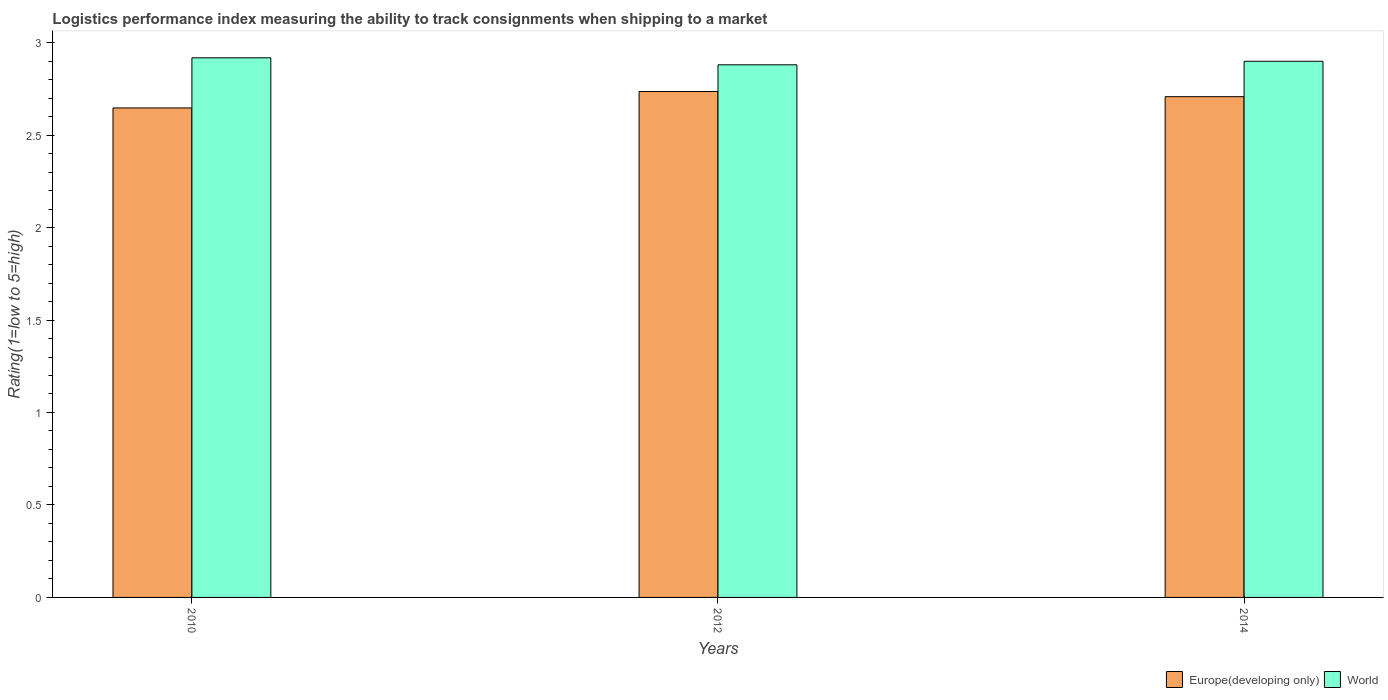How many different coloured bars are there?
Keep it short and to the point. 2. How many groups of bars are there?
Ensure brevity in your answer.  3. Are the number of bars on each tick of the X-axis equal?
Give a very brief answer. Yes. How many bars are there on the 2nd tick from the left?
Keep it short and to the point. 2. How many bars are there on the 2nd tick from the right?
Offer a terse response. 2. In how many cases, is the number of bars for a given year not equal to the number of legend labels?
Provide a succinct answer. 0. What is the Logistic performance index in Europe(developing only) in 2012?
Make the answer very short. 2.74. Across all years, what is the maximum Logistic performance index in World?
Keep it short and to the point. 2.92. Across all years, what is the minimum Logistic performance index in World?
Offer a very short reply. 2.88. In which year was the Logistic performance index in World maximum?
Offer a terse response. 2010. What is the total Logistic performance index in Europe(developing only) in the graph?
Offer a very short reply. 8.09. What is the difference between the Logistic performance index in Europe(developing only) in 2010 and that in 2014?
Provide a short and direct response. -0.06. What is the difference between the Logistic performance index in World in 2010 and the Logistic performance index in Europe(developing only) in 2014?
Offer a terse response. 0.21. What is the average Logistic performance index in World per year?
Give a very brief answer. 2.9. In the year 2010, what is the difference between the Logistic performance index in World and Logistic performance index in Europe(developing only)?
Offer a terse response. 0.27. What is the ratio of the Logistic performance index in World in 2010 to that in 2012?
Offer a very short reply. 1.01. Is the difference between the Logistic performance index in World in 2010 and 2012 greater than the difference between the Logistic performance index in Europe(developing only) in 2010 and 2012?
Give a very brief answer. Yes. What is the difference between the highest and the second highest Logistic performance index in Europe(developing only)?
Your response must be concise. 0.03. What is the difference between the highest and the lowest Logistic performance index in World?
Make the answer very short. 0.04. What does the 2nd bar from the left in 2014 represents?
Your answer should be compact. World. What does the 1st bar from the right in 2010 represents?
Provide a succinct answer. World. Are all the bars in the graph horizontal?
Offer a terse response. No. Does the graph contain grids?
Give a very brief answer. No. How many legend labels are there?
Your answer should be very brief. 2. What is the title of the graph?
Give a very brief answer. Logistics performance index measuring the ability to track consignments when shipping to a market. What is the label or title of the Y-axis?
Offer a terse response. Rating(1=low to 5=high). What is the Rating(1=low to 5=high) of Europe(developing only) in 2010?
Your response must be concise. 2.65. What is the Rating(1=low to 5=high) in World in 2010?
Ensure brevity in your answer.  2.92. What is the Rating(1=low to 5=high) of Europe(developing only) in 2012?
Offer a very short reply. 2.74. What is the Rating(1=low to 5=high) in World in 2012?
Your answer should be very brief. 2.88. What is the Rating(1=low to 5=high) in Europe(developing only) in 2014?
Your answer should be very brief. 2.71. What is the Rating(1=low to 5=high) of World in 2014?
Offer a terse response. 2.9. Across all years, what is the maximum Rating(1=low to 5=high) of Europe(developing only)?
Keep it short and to the point. 2.74. Across all years, what is the maximum Rating(1=low to 5=high) of World?
Your response must be concise. 2.92. Across all years, what is the minimum Rating(1=low to 5=high) of Europe(developing only)?
Make the answer very short. 2.65. Across all years, what is the minimum Rating(1=low to 5=high) of World?
Keep it short and to the point. 2.88. What is the total Rating(1=low to 5=high) in Europe(developing only) in the graph?
Your answer should be very brief. 8.09. What is the total Rating(1=low to 5=high) of World in the graph?
Your answer should be compact. 8.7. What is the difference between the Rating(1=low to 5=high) of Europe(developing only) in 2010 and that in 2012?
Your answer should be compact. -0.09. What is the difference between the Rating(1=low to 5=high) in World in 2010 and that in 2012?
Make the answer very short. 0.04. What is the difference between the Rating(1=low to 5=high) in Europe(developing only) in 2010 and that in 2014?
Keep it short and to the point. -0.06. What is the difference between the Rating(1=low to 5=high) in World in 2010 and that in 2014?
Give a very brief answer. 0.02. What is the difference between the Rating(1=low to 5=high) in Europe(developing only) in 2012 and that in 2014?
Offer a terse response. 0.03. What is the difference between the Rating(1=low to 5=high) of World in 2012 and that in 2014?
Your answer should be very brief. -0.02. What is the difference between the Rating(1=low to 5=high) of Europe(developing only) in 2010 and the Rating(1=low to 5=high) of World in 2012?
Offer a terse response. -0.23. What is the difference between the Rating(1=low to 5=high) in Europe(developing only) in 2010 and the Rating(1=low to 5=high) in World in 2014?
Your answer should be compact. -0.25. What is the difference between the Rating(1=low to 5=high) in Europe(developing only) in 2012 and the Rating(1=low to 5=high) in World in 2014?
Keep it short and to the point. -0.16. What is the average Rating(1=low to 5=high) of Europe(developing only) per year?
Make the answer very short. 2.7. What is the average Rating(1=low to 5=high) of World per year?
Your answer should be compact. 2.9. In the year 2010, what is the difference between the Rating(1=low to 5=high) in Europe(developing only) and Rating(1=low to 5=high) in World?
Your answer should be compact. -0.27. In the year 2012, what is the difference between the Rating(1=low to 5=high) in Europe(developing only) and Rating(1=low to 5=high) in World?
Provide a succinct answer. -0.14. In the year 2014, what is the difference between the Rating(1=low to 5=high) in Europe(developing only) and Rating(1=low to 5=high) in World?
Offer a terse response. -0.19. What is the ratio of the Rating(1=low to 5=high) in Europe(developing only) in 2010 to that in 2012?
Offer a terse response. 0.97. What is the ratio of the Rating(1=low to 5=high) of World in 2010 to that in 2012?
Provide a short and direct response. 1.01. What is the ratio of the Rating(1=low to 5=high) of Europe(developing only) in 2010 to that in 2014?
Ensure brevity in your answer.  0.98. What is the ratio of the Rating(1=low to 5=high) in World in 2010 to that in 2014?
Provide a succinct answer. 1.01. What is the ratio of the Rating(1=low to 5=high) in Europe(developing only) in 2012 to that in 2014?
Make the answer very short. 1.01. What is the difference between the highest and the second highest Rating(1=low to 5=high) of Europe(developing only)?
Your response must be concise. 0.03. What is the difference between the highest and the second highest Rating(1=low to 5=high) of World?
Your answer should be very brief. 0.02. What is the difference between the highest and the lowest Rating(1=low to 5=high) of Europe(developing only)?
Provide a short and direct response. 0.09. What is the difference between the highest and the lowest Rating(1=low to 5=high) of World?
Offer a terse response. 0.04. 